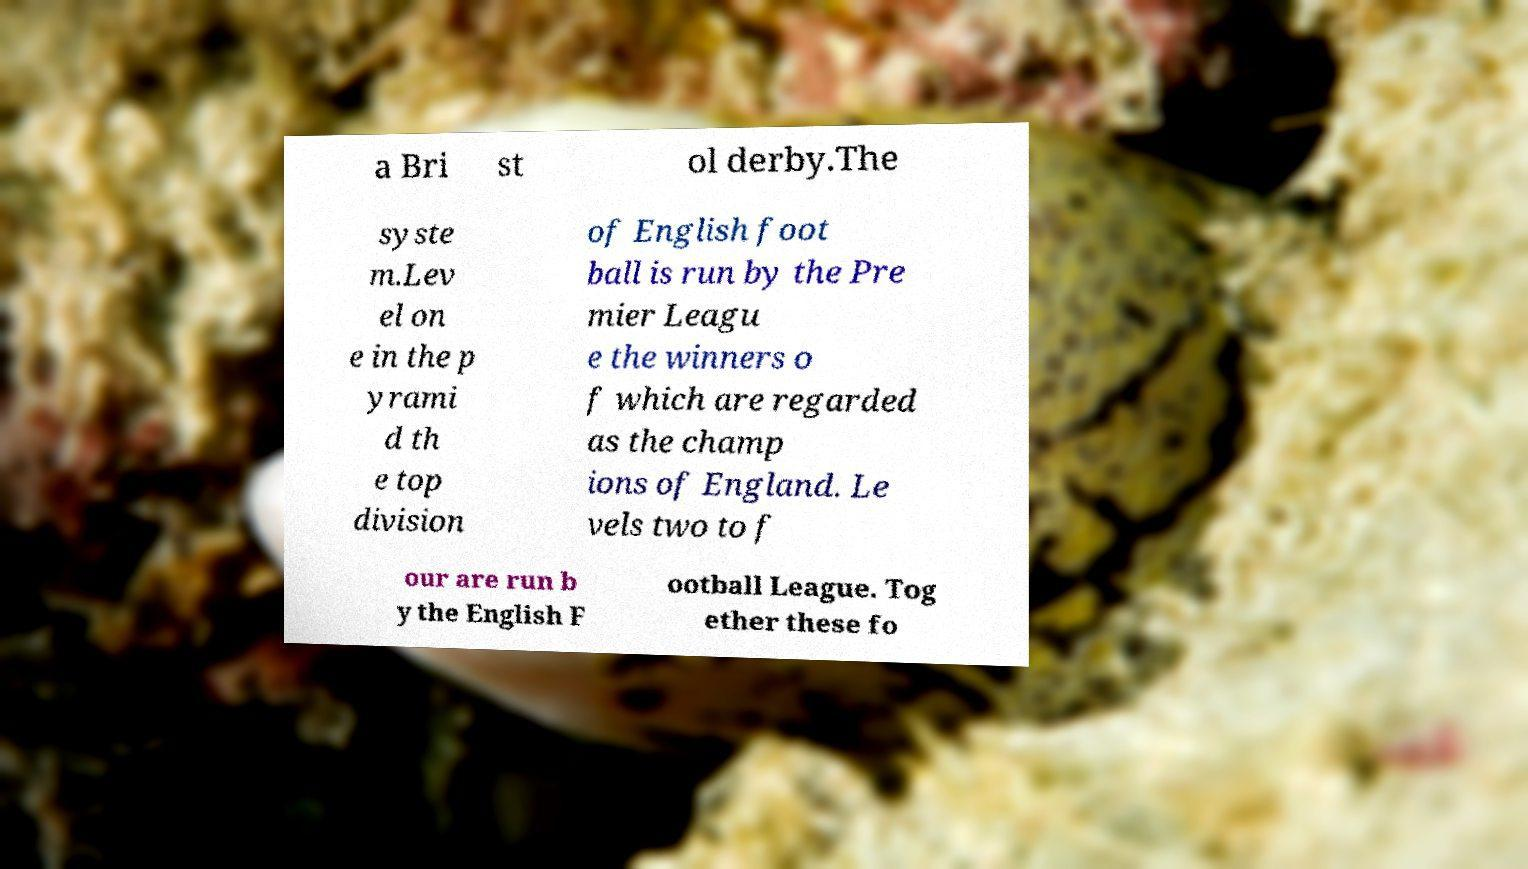I need the written content from this picture converted into text. Can you do that? a Bri st ol derby.The syste m.Lev el on e in the p yrami d th e top division of English foot ball is run by the Pre mier Leagu e the winners o f which are regarded as the champ ions of England. Le vels two to f our are run b y the English F ootball League. Tog ether these fo 